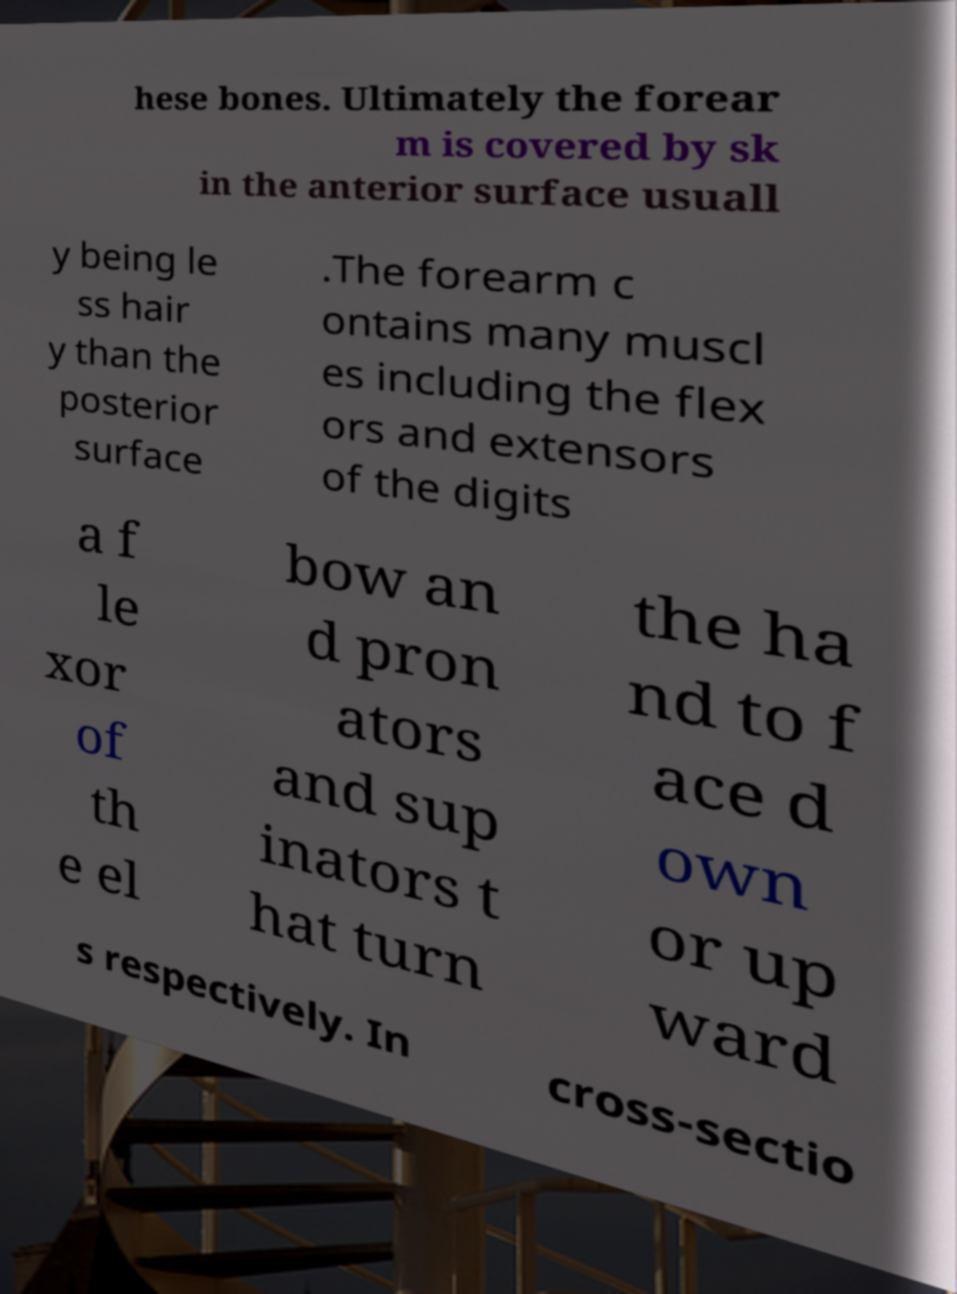Please identify and transcribe the text found in this image. hese bones. Ultimately the forear m is covered by sk in the anterior surface usuall y being le ss hair y than the posterior surface .The forearm c ontains many muscl es including the flex ors and extensors of the digits a f le xor of th e el bow an d pron ators and sup inators t hat turn the ha nd to f ace d own or up ward s respectively. In cross-sectio 